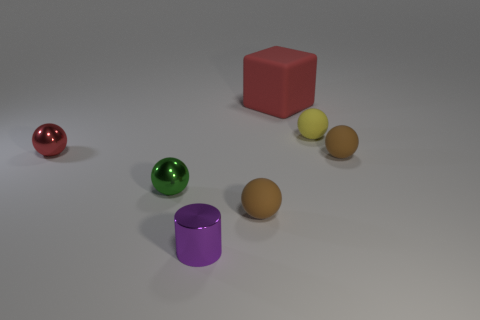How many spherical objects are in the image? I see a total of four spherical objects in varying sizes and colors positioned on the surface in the image. 